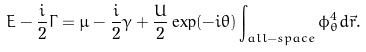<formula> <loc_0><loc_0><loc_500><loc_500>E - \frac { i } { 2 } \Gamma = \mu - \frac { i } { 2 } \gamma + \frac { U } { 2 } \exp ( { - i \theta } ) \int _ { a l l - s p a c e } \phi _ { \theta } ^ { 4 } d \vec { r } .</formula> 